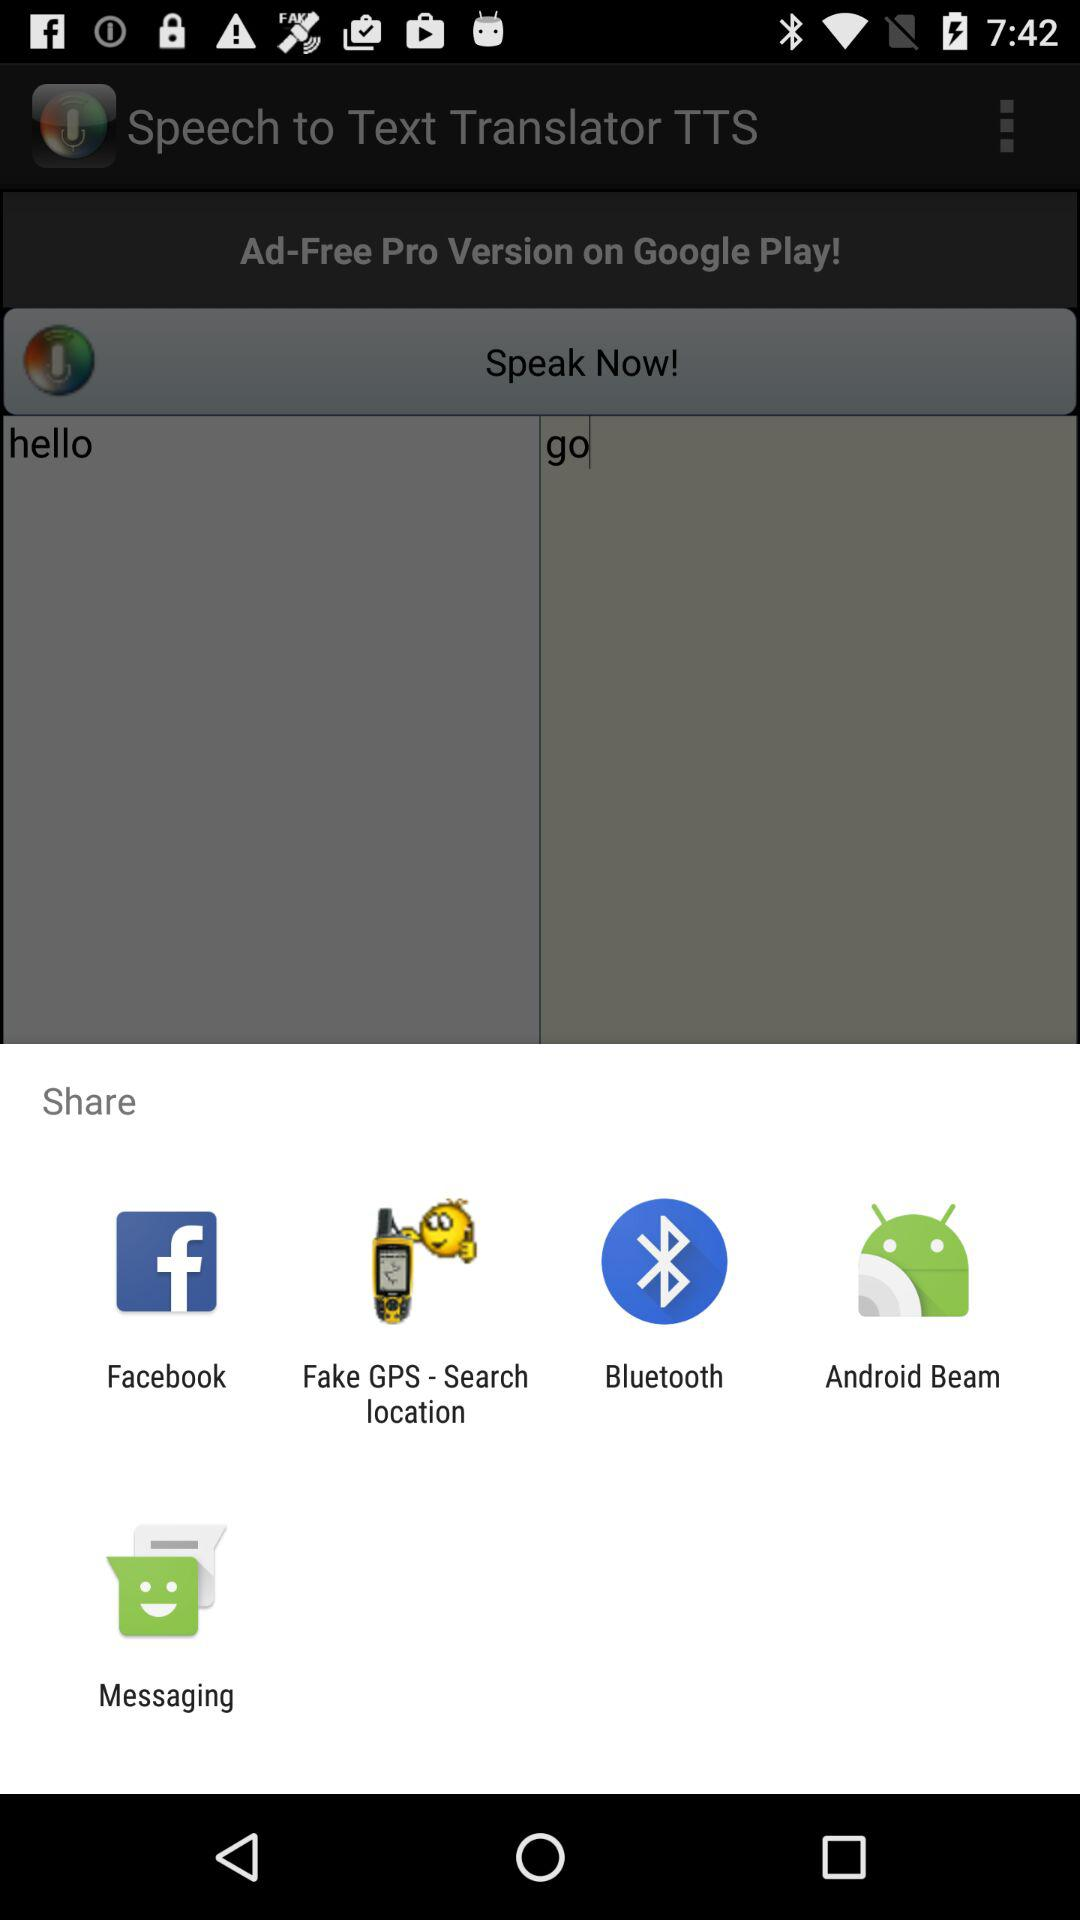Through what applications can we share with? The applications are "Facebook", "Fake GPS - Search location", "Bluetooth", "Android Beam" and "Messaging". 